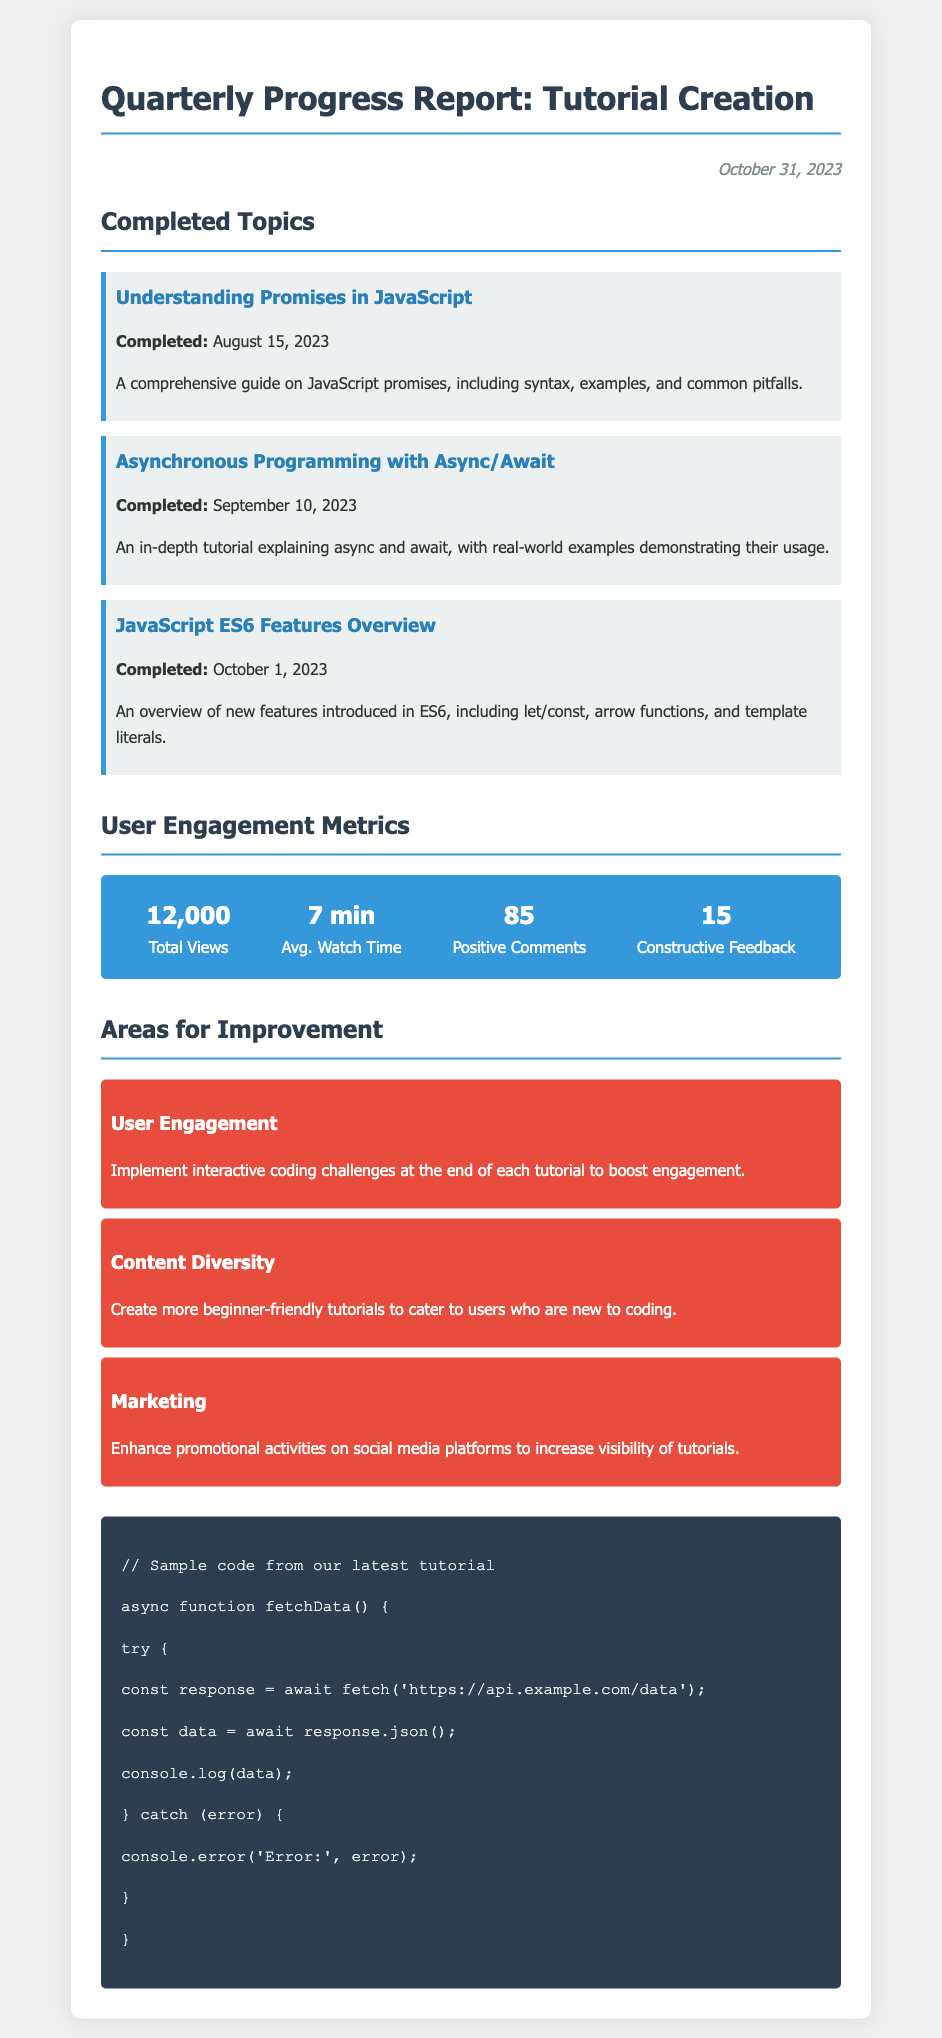What is the date of the report? The date is mentioned in the memo header.
Answer: October 31, 2023 What is the title of the first completed topic? The title of the first completed topic is provided in the Completed Topics section.
Answer: Understanding Promises in JavaScript How many total views were there? The total views metric is displayed in the User Engagement Metrics section.
Answer: 12,000 When was the tutorial on Async/Await completed? The completion date is specified in the description of the completed topic.
Answer: September 10, 2023 What is the average watch time for the tutorials? The average watch time metric is listed under User Engagement Metrics.
Answer: 7 min What constructive feedback count is provided? The constructive feedback count is indicated in the metrics section.
Answer: 15 What is suggested to improve user engagement? The suggestions for improvement are clearly outlined in the Areas for Improvement section.
Answer: Implement interactive coding challenges How many positive comments were received? The positive comments metric is found in the User Engagement Metrics section.
Answer: 85 What is the overarching theme of the tutorial topics completed? The tutorial topics focus on async programming concepts in JavaScript.
Answer: Async programming concepts 